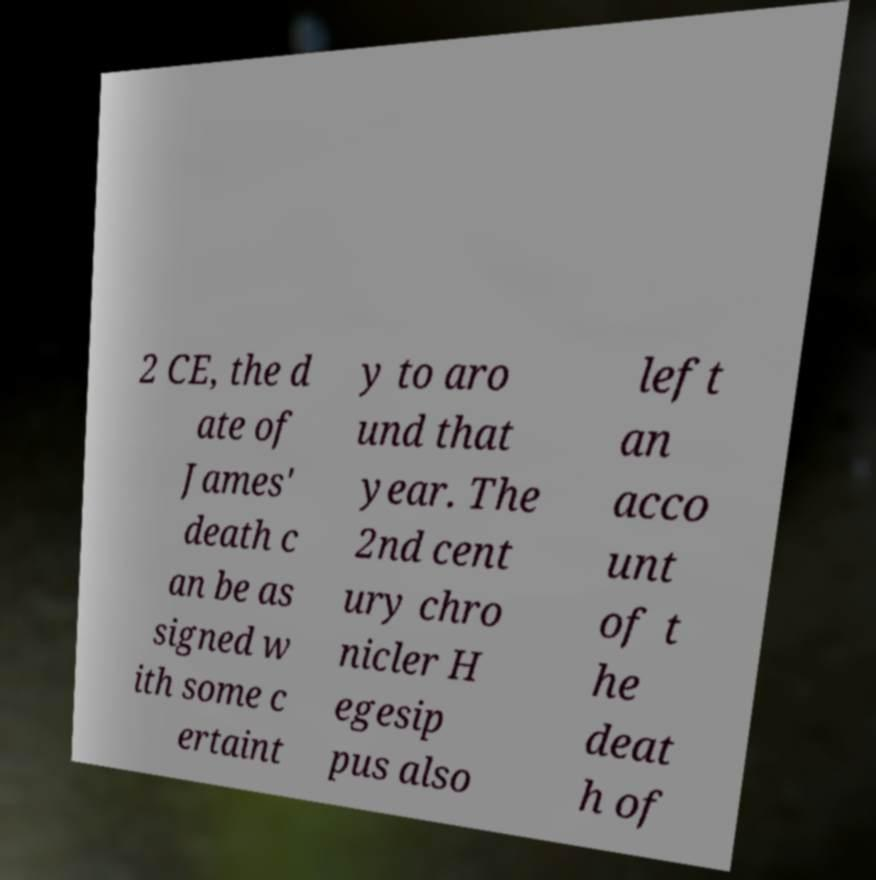What messages or text are displayed in this image? I need them in a readable, typed format. 2 CE, the d ate of James' death c an be as signed w ith some c ertaint y to aro und that year. The 2nd cent ury chro nicler H egesip pus also left an acco unt of t he deat h of 